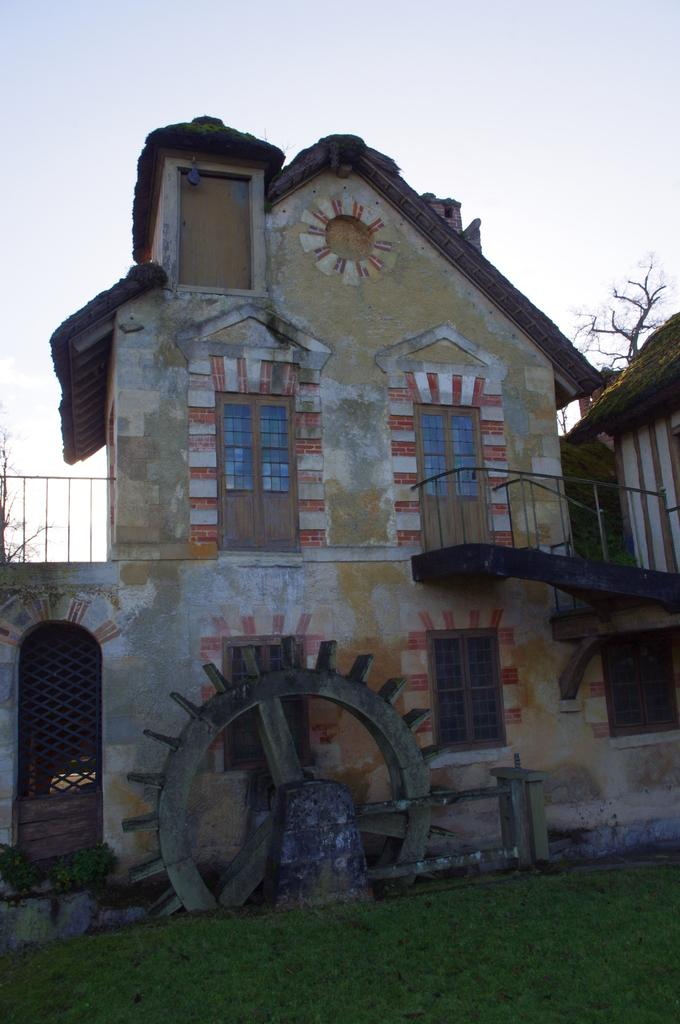What type of structures are visible in the image? There are buildings with roofs and windows in the image. Where are the buildings located? The buildings are on the ground. What type of vegetation is present on the ground? There is grass on the ground. What can be seen in the background of the image? There are trees in the background of the image. What is visible in the sky? There are clouds in the sky. What type of pan is being used to cook food in the image? There is no pan or cooking activity visible in the image; it features buildings, grass, trees, and clouds. 